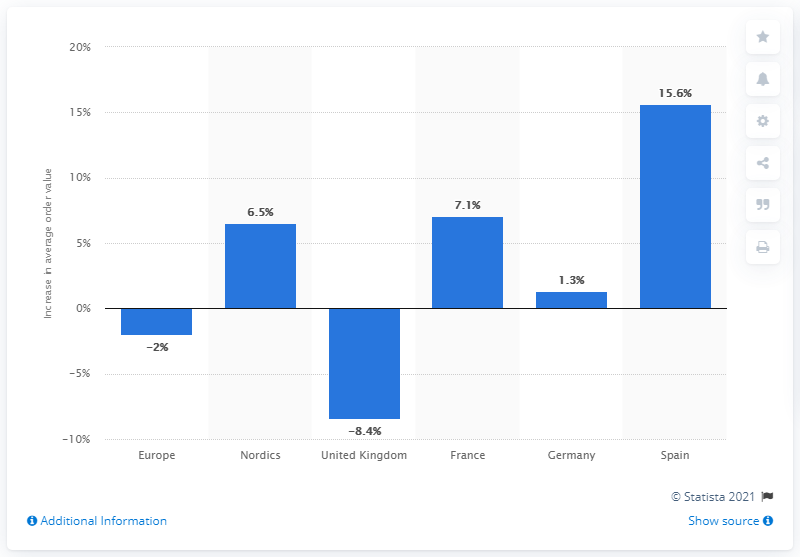List a handful of essential elements in this visual. Spain demonstrated a growth of 15.6 percent. 